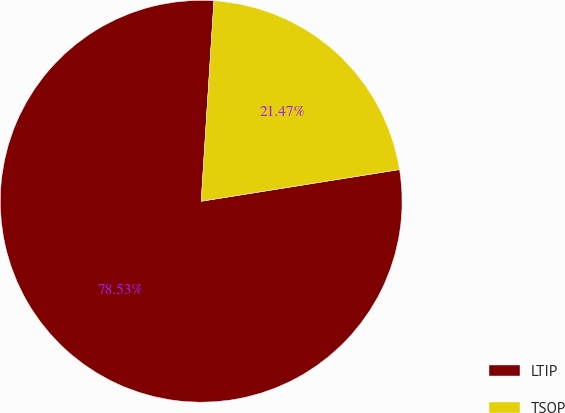Convert chart to OTSL. <chart><loc_0><loc_0><loc_500><loc_500><pie_chart><fcel>LTIP<fcel>TSOP<nl><fcel>78.53%<fcel>21.47%<nl></chart> 